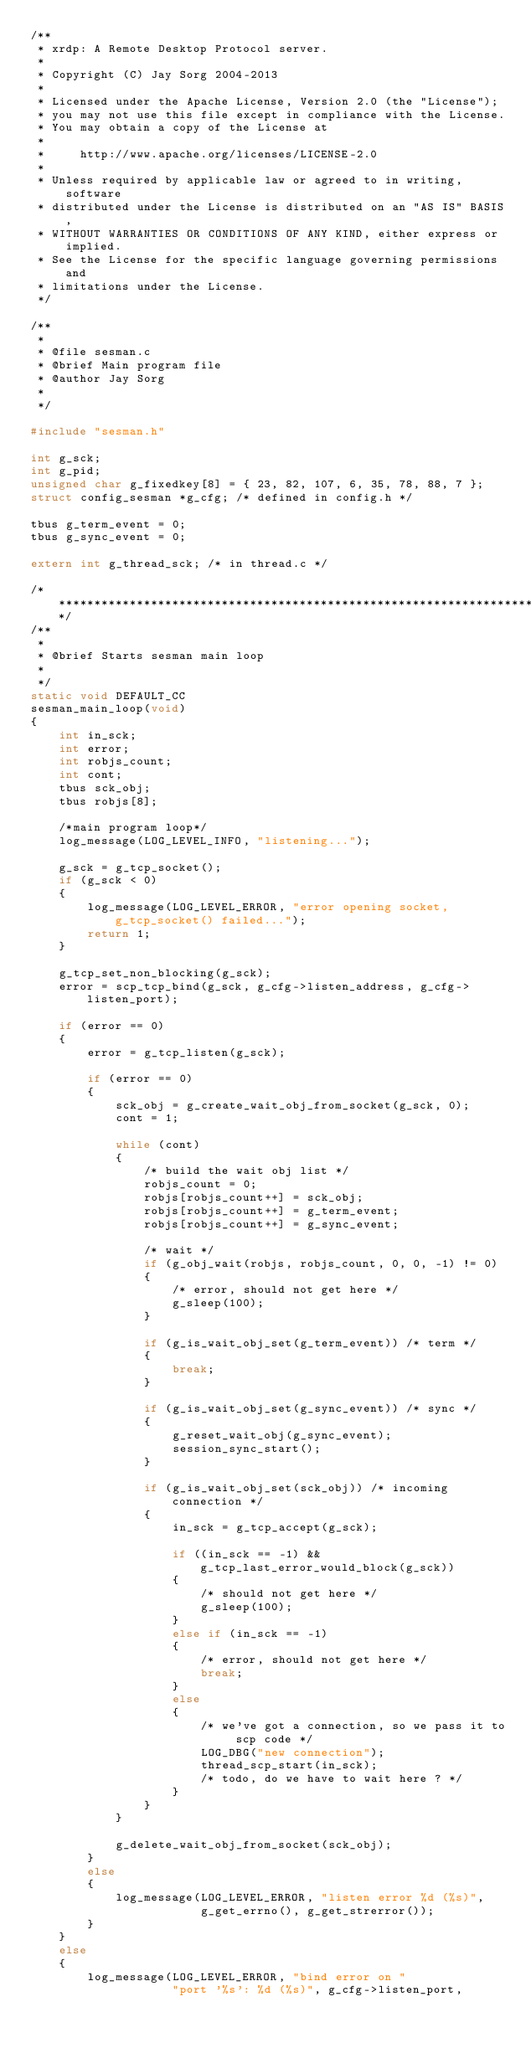Convert code to text. <code><loc_0><loc_0><loc_500><loc_500><_C_>/**
 * xrdp: A Remote Desktop Protocol server.
 *
 * Copyright (C) Jay Sorg 2004-2013
 *
 * Licensed under the Apache License, Version 2.0 (the "License");
 * you may not use this file except in compliance with the License.
 * You may obtain a copy of the License at
 *
 *     http://www.apache.org/licenses/LICENSE-2.0
 *
 * Unless required by applicable law or agreed to in writing, software
 * distributed under the License is distributed on an "AS IS" BASIS,
 * WITHOUT WARRANTIES OR CONDITIONS OF ANY KIND, either express or implied.
 * See the License for the specific language governing permissions and
 * limitations under the License.
 */

/**
 *
 * @file sesman.c
 * @brief Main program file
 * @author Jay Sorg
 *
 */

#include "sesman.h"

int g_sck;
int g_pid;
unsigned char g_fixedkey[8] = { 23, 82, 107, 6, 35, 78, 88, 7 };
struct config_sesman *g_cfg; /* defined in config.h */

tbus g_term_event = 0;
tbus g_sync_event = 0;

extern int g_thread_sck; /* in thread.c */

/******************************************************************************/
/**
 *
 * @brief Starts sesman main loop
 *
 */
static void DEFAULT_CC
sesman_main_loop(void)
{
    int in_sck;
    int error;
    int robjs_count;
    int cont;
    tbus sck_obj;
    tbus robjs[8];

    /*main program loop*/
    log_message(LOG_LEVEL_INFO, "listening...");

    g_sck = g_tcp_socket();
    if (g_sck < 0)
    {
        log_message(LOG_LEVEL_ERROR, "error opening socket, g_tcp_socket() failed...");
        return 1;
    }

    g_tcp_set_non_blocking(g_sck);
    error = scp_tcp_bind(g_sck, g_cfg->listen_address, g_cfg->listen_port);

    if (error == 0)
    {
        error = g_tcp_listen(g_sck);

        if (error == 0)
        {
            sck_obj = g_create_wait_obj_from_socket(g_sck, 0);
            cont = 1;

            while (cont)
            {
                /* build the wait obj list */
                robjs_count = 0;
                robjs[robjs_count++] = sck_obj;
                robjs[robjs_count++] = g_term_event;
                robjs[robjs_count++] = g_sync_event;

                /* wait */
                if (g_obj_wait(robjs, robjs_count, 0, 0, -1) != 0)
                {
                    /* error, should not get here */
                    g_sleep(100);
                }

                if (g_is_wait_obj_set(g_term_event)) /* term */
                {
                    break;
                }

                if (g_is_wait_obj_set(g_sync_event)) /* sync */
                {
                    g_reset_wait_obj(g_sync_event);
                    session_sync_start();
                }

                if (g_is_wait_obj_set(sck_obj)) /* incoming connection */
                {
                    in_sck = g_tcp_accept(g_sck);

                    if ((in_sck == -1) && g_tcp_last_error_would_block(g_sck))
                    {
                        /* should not get here */
                        g_sleep(100);
                    }
                    else if (in_sck == -1)
                    {
                        /* error, should not get here */
                        break;
                    }
                    else
                    {
                        /* we've got a connection, so we pass it to scp code */
                        LOG_DBG("new connection");
                        thread_scp_start(in_sck);
                        /* todo, do we have to wait here ? */
                    }
                }
            }

            g_delete_wait_obj_from_socket(sck_obj);
        }
        else
        {
            log_message(LOG_LEVEL_ERROR, "listen error %d (%s)",
                        g_get_errno(), g_get_strerror());
        }
    }
    else
    {
        log_message(LOG_LEVEL_ERROR, "bind error on "
                    "port '%s': %d (%s)", g_cfg->listen_port,</code> 